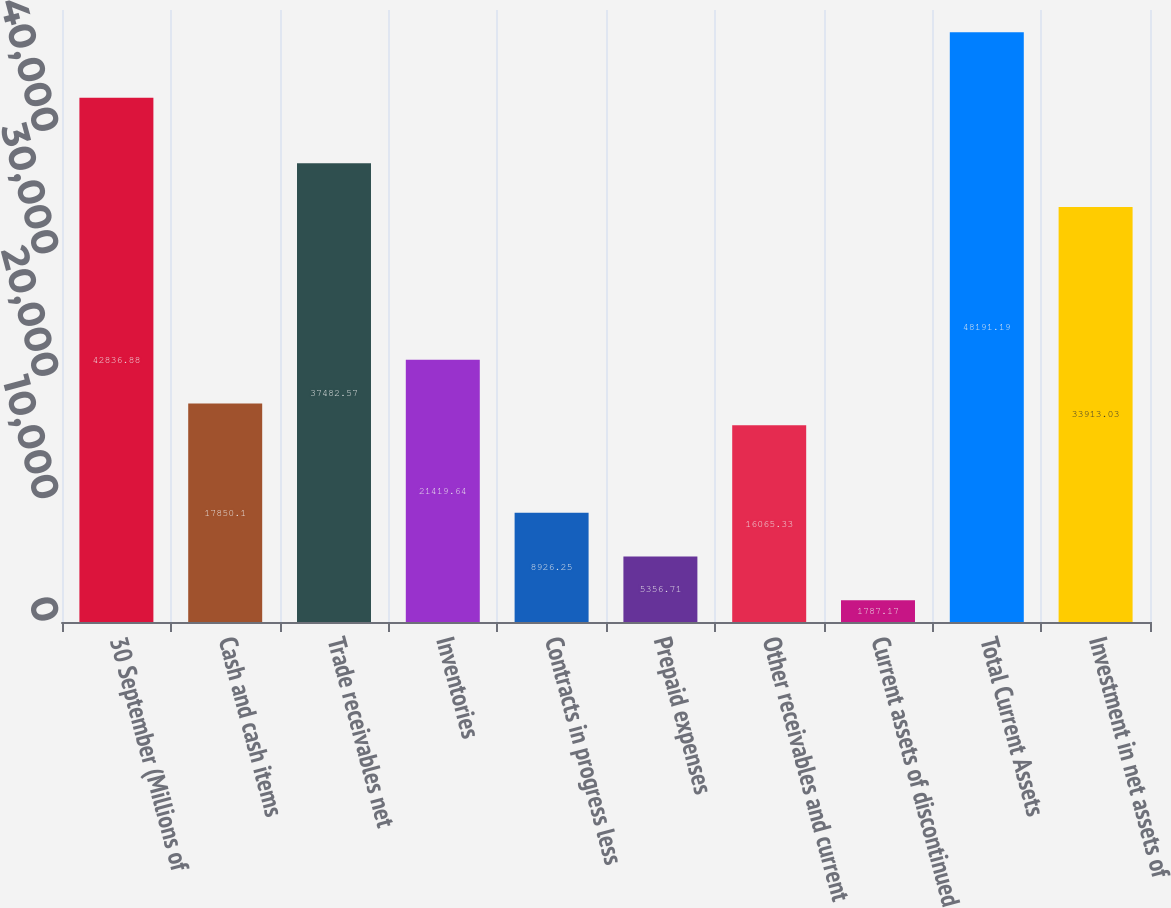Convert chart to OTSL. <chart><loc_0><loc_0><loc_500><loc_500><bar_chart><fcel>30 September (Millions of<fcel>Cash and cash items<fcel>Trade receivables net<fcel>Inventories<fcel>Contracts in progress less<fcel>Prepaid expenses<fcel>Other receivables and current<fcel>Current assets of discontinued<fcel>Total Current Assets<fcel>Investment in net assets of<nl><fcel>42836.9<fcel>17850.1<fcel>37482.6<fcel>21419.6<fcel>8926.25<fcel>5356.71<fcel>16065.3<fcel>1787.17<fcel>48191.2<fcel>33913<nl></chart> 